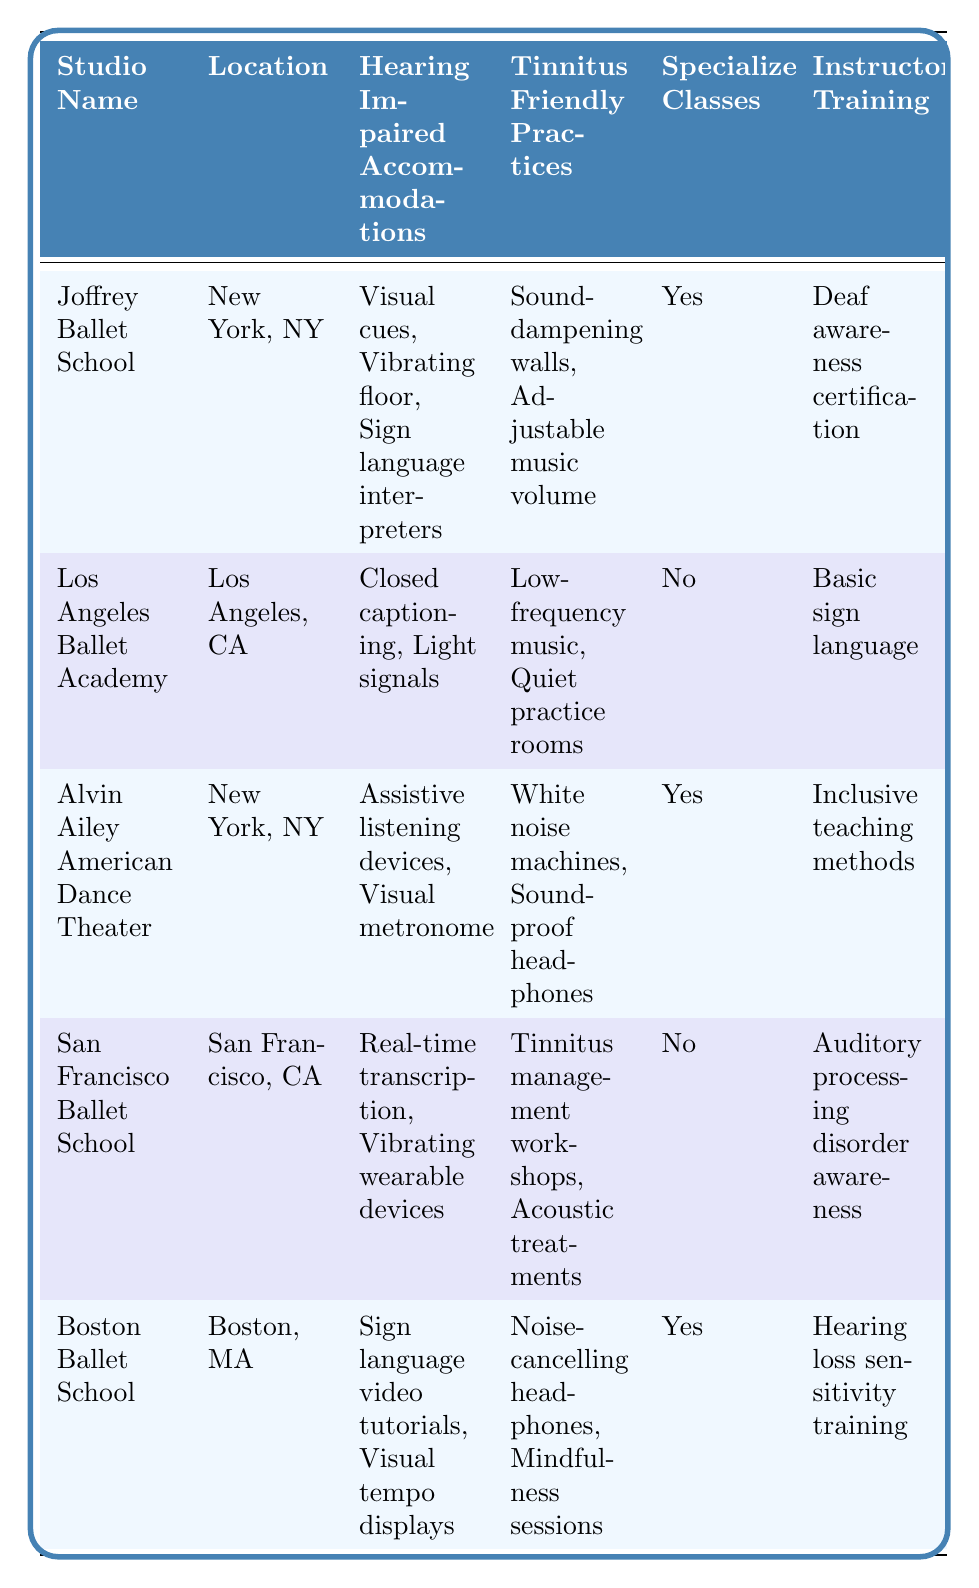What accommodations does the Joffrey Ballet School offer for hearing-impaired dancers? The table lists the hearing-impaired accommodations for the Joffrey Ballet School as visual cues for rhythm, vibrating floor technology, and sign language interpreters.
Answer: Visual cues, vibrating floor technology, sign language interpreters Is there a studio that provides specialized classes for hearing-impaired dancers? The table indicates that Joffrey Ballet School, Alvin Ailey American Dance Theater, and Boston Ballet School offer specialized classes for hearing-impaired dancers.
Answer: Yes, three studios provide specialized classes What tinnitus-friendly practices are available at the Los Angeles Ballet Academy? According to the table, the tinnitus-friendly practices at the Los Angeles Ballet Academy include low-frequency music options and quiet practice rooms.
Answer: Low-frequency music, quiet practice rooms How many studios have deaf awareness certification training for instructors? By examining the table, I can see that only the Joffrey Ballet School has deaf awareness certification for instructor training, indicating one studio has this certification.
Answer: One studio Which studio has the most tinnitus-friendly practices? I find that both the Alvin Ailey American Dance Theater and the Boston Ballet School have two tinnitus-friendly practices listed; thus, we need to compare them and find that they both have the highest count.
Answer: Alvin Ailey American Dance Theater and Boston Ballet School Does the San Francisco Ballet School offer specialized classes? The table shows that the San Francisco Ballet School does not provide specialized classes for hearing-impaired dancers, as indicated by the "No" value in that column.
Answer: No Which studio is located in New York, NY, and offers specialized classes? The table presents two studios located in New York, NY: Joffrey Ballet School and Alvin Ailey American Dance Theater. Since both offer specialized classes, they meet the criteria.
Answer: Joffrey Ballet School and Alvin Ailey American Dance Theater What hearing-impaired accommodations are unique to the Boston Ballet School? The Boston Ballet School provides sign language video tutorials and visual tempo displays as its hearing-impaired accommodations, which are not mentioned by other studios.
Answer: Sign language video tutorials, visual tempo displays Which studio has the highest number of accommodations for both hearing-impaired dancers and tinnitus-friendly practices combined? To assess which studio has the highest number of accommodations, I will tally the accommodation types. Joffrey Ballet has 5, Los Angeles Ballet has 4, Alvin Ailey has 5, San Francisco has 4, and Boston has 4, revealing that Joffrey Ballet School and Alvin Ailey American Dance Theater each have the highest total of 5 accommodations.
Answer: Joffrey Ballet School and Alvin Ailey American Dance Theater 